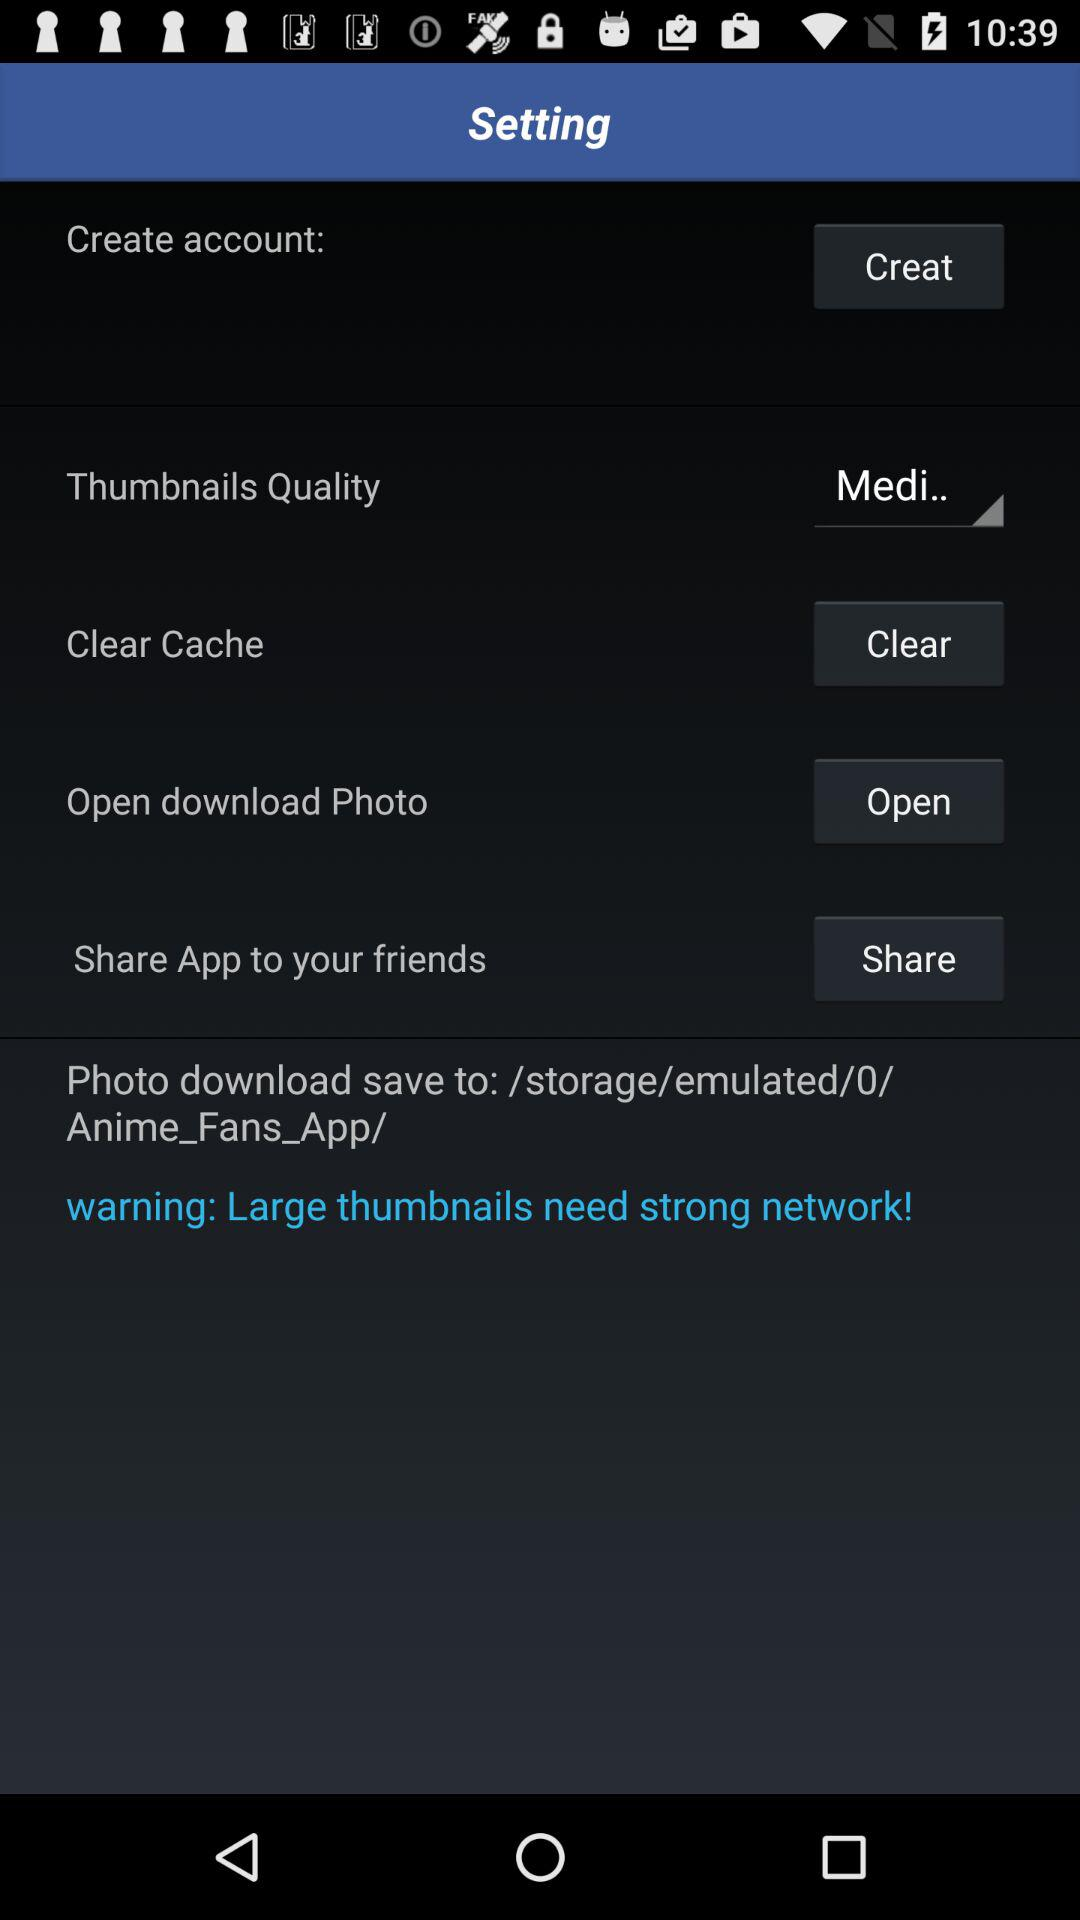What is the setting for thumbnail quality? The setting for thumbnail quality is "Medi..". 